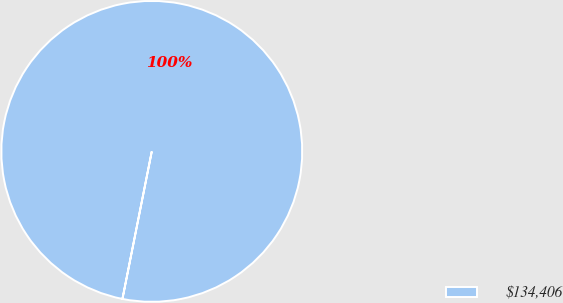Convert chart. <chart><loc_0><loc_0><loc_500><loc_500><pie_chart><fcel>$134,406<nl><fcel>100.0%<nl></chart> 